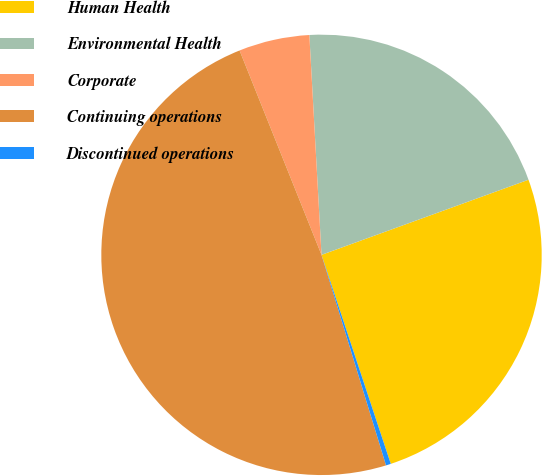Convert chart to OTSL. <chart><loc_0><loc_0><loc_500><loc_500><pie_chart><fcel>Human Health<fcel>Environmental Health<fcel>Corporate<fcel>Continuing operations<fcel>Discontinued operations<nl><fcel>25.45%<fcel>20.34%<fcel>5.19%<fcel>48.67%<fcel>0.36%<nl></chart> 